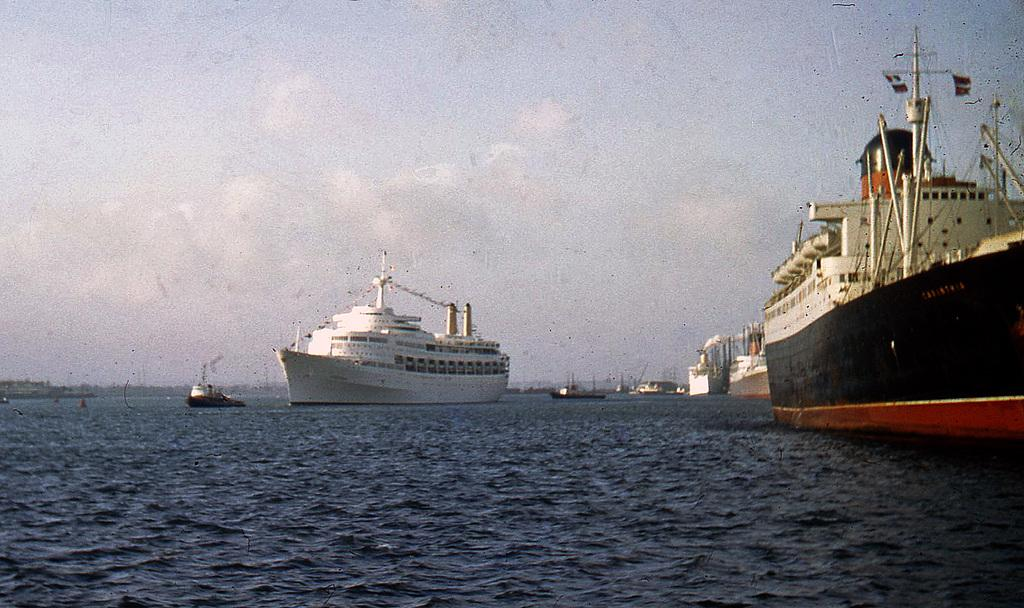What is the main subject of the image? The main subject of the image is ships. Where are the ships located? The ships are on the water. Can you describe the color of one of the ships? One ship is white in color. What can be seen in the background of the image? The sky is visible in the background of the image. What is the color of the sky in the image? The color of the sky is white. Can you tell me how many doctors are on the ship in the image? There is no doctor present in the image; it features ships on the water. What type of stem can be seen growing from the ship in the image? There is no stem growing from the ship in the image; it is a vessel on the water. 